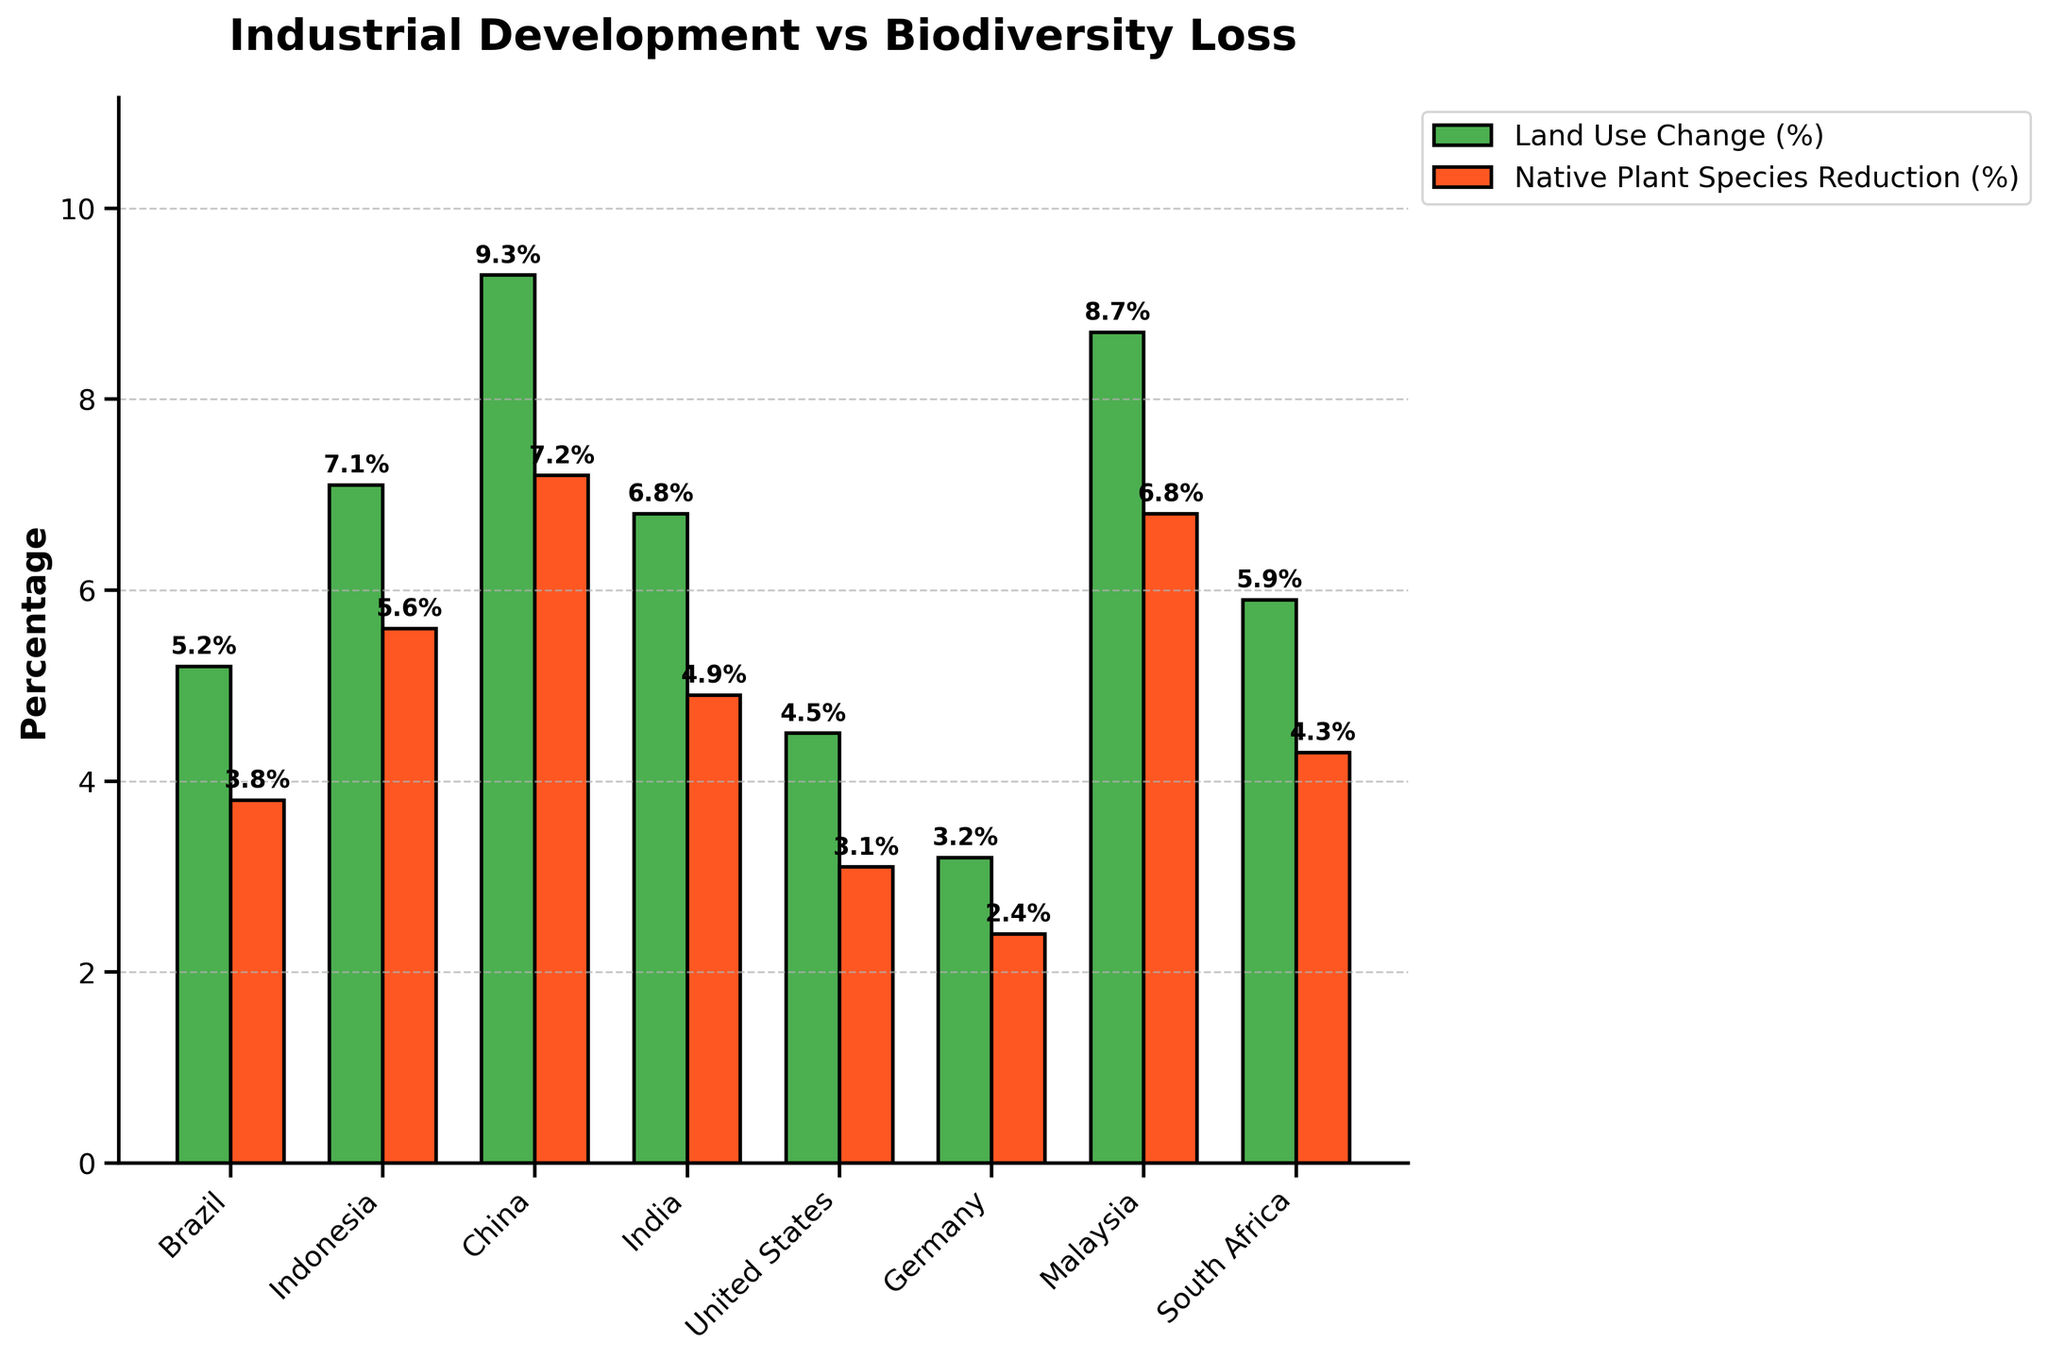What is the overall trend in the percentage of land use change for industrial purposes from 1990 to 2025? The general trend shows a fluctuation with some peaks and troughs but an overall increase in land use change percentage over time with notable peaks in 2000 and 2020.
Answer: Increasing with fluctuations Which country experienced the highest percentage of native plant species reduction? By comparing the height of the red bars for each country, it is clear that China experienced the highest percentage of native plant species reduction at 7.2%.
Answer: China Between Brazil and Malaysia, which country had a greater percentage of land use change for industrial purposes in their respective years? Comparing the heights of the green bars for Brazil and Malaysia shows that Malaysia (8.7%) had a greater percentage than Brazil (5.2%).
Answer: Malaysia What is the combined percentage of land use change for industrial purposes for Germany and the United States? By adding the land use change percentages for Germany (3.2%) and the United States (4.5%), the combined total is 7.7%.
Answer: 7.7% Between 2015 and 2020, what was the average percentage reduction in native plant species across the countries mentioned in those years? The data indicates that Germany in 2015 and Malaysia in 2020 had reductions of 2.4% and 6.8%, respectively. The average is calculated as (2.4 + 6.8) / 2 = 4.6%.
Answer: 4.6% Which country had a higher percentage reduction in native plant species: Indonesia in 1995 or South Africa in 2025? Comparing the heights of the red bars for Indonesia (5.6%) and South Africa (4.3%) shows that Indonesia had a higher percentage reduction.
Answer: Indonesia How many countries experienced a reduction in native plant species greater than 5%? The countries with a native plant species reduction greater than 5% are Indonesia (5.6%), China (7.2%), and Malaysia (6.8%). This totals to three countries.
Answer: Three Is there a direct correlation between the percentage of land use change and the reduction in native plant species? From visual inspection, countries with higher percentages of land use change tend to have higher reductions in native plant species, suggesting a positive correlation.
Answer: Yes What was the land use change percentage difference between India in 2005 and the United States in 2010? The difference in percentages is calculated as 6.8% (India) - 4.5% (United States) = 2.3%.
Answer: 2.3% 